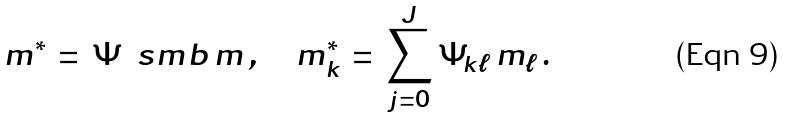Convert formula to latex. <formula><loc_0><loc_0><loc_500><loc_500>m ^ { * } \, = \, \Psi \, \ s m b \, m \, , \quad m ^ { * } _ { k } \, = \, \sum _ { j = 0 } ^ { J } \Psi _ { k \ell } \, m _ { \ell } \, .</formula> 